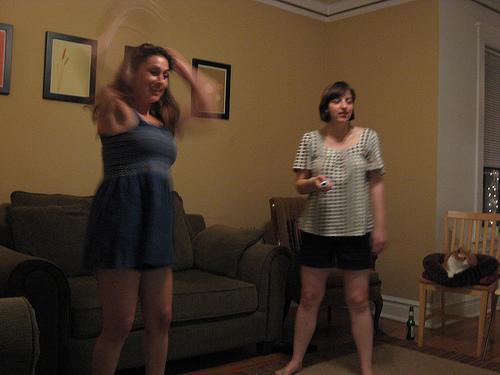How many framed pictures can be seen on the wall?
Give a very brief answer. 4. How many cats are shown?
Give a very brief answer. 1. How many people are visible?
Give a very brief answer. 2. 